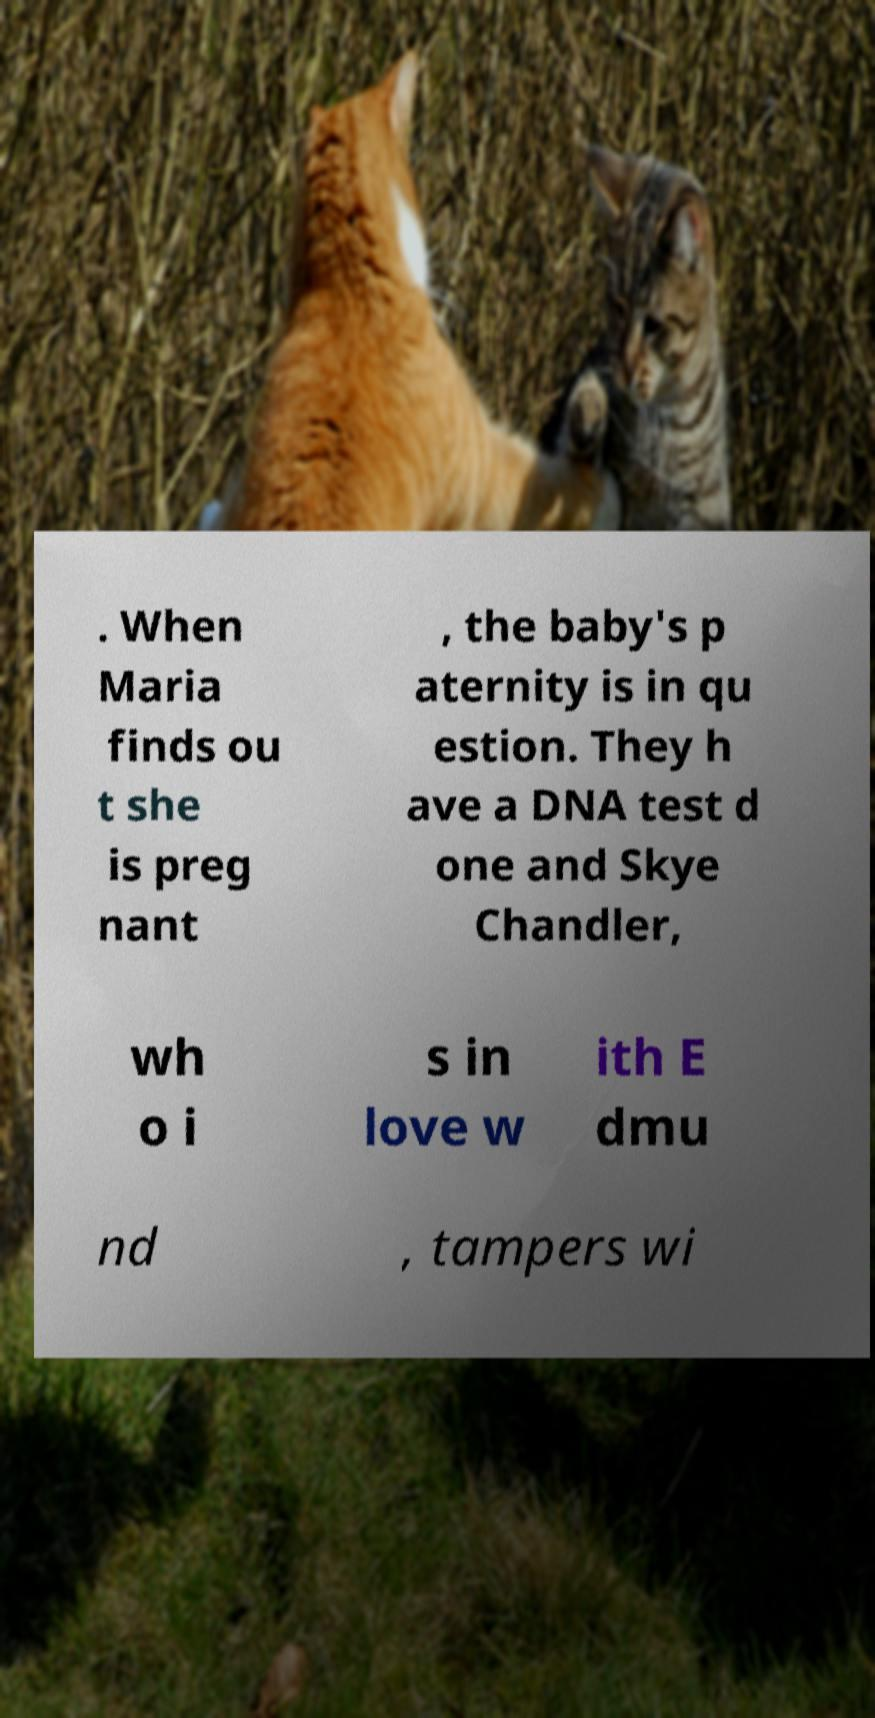Can you accurately transcribe the text from the provided image for me? . When Maria finds ou t she is preg nant , the baby's p aternity is in qu estion. They h ave a DNA test d one and Skye Chandler, wh o i s in love w ith E dmu nd , tampers wi 